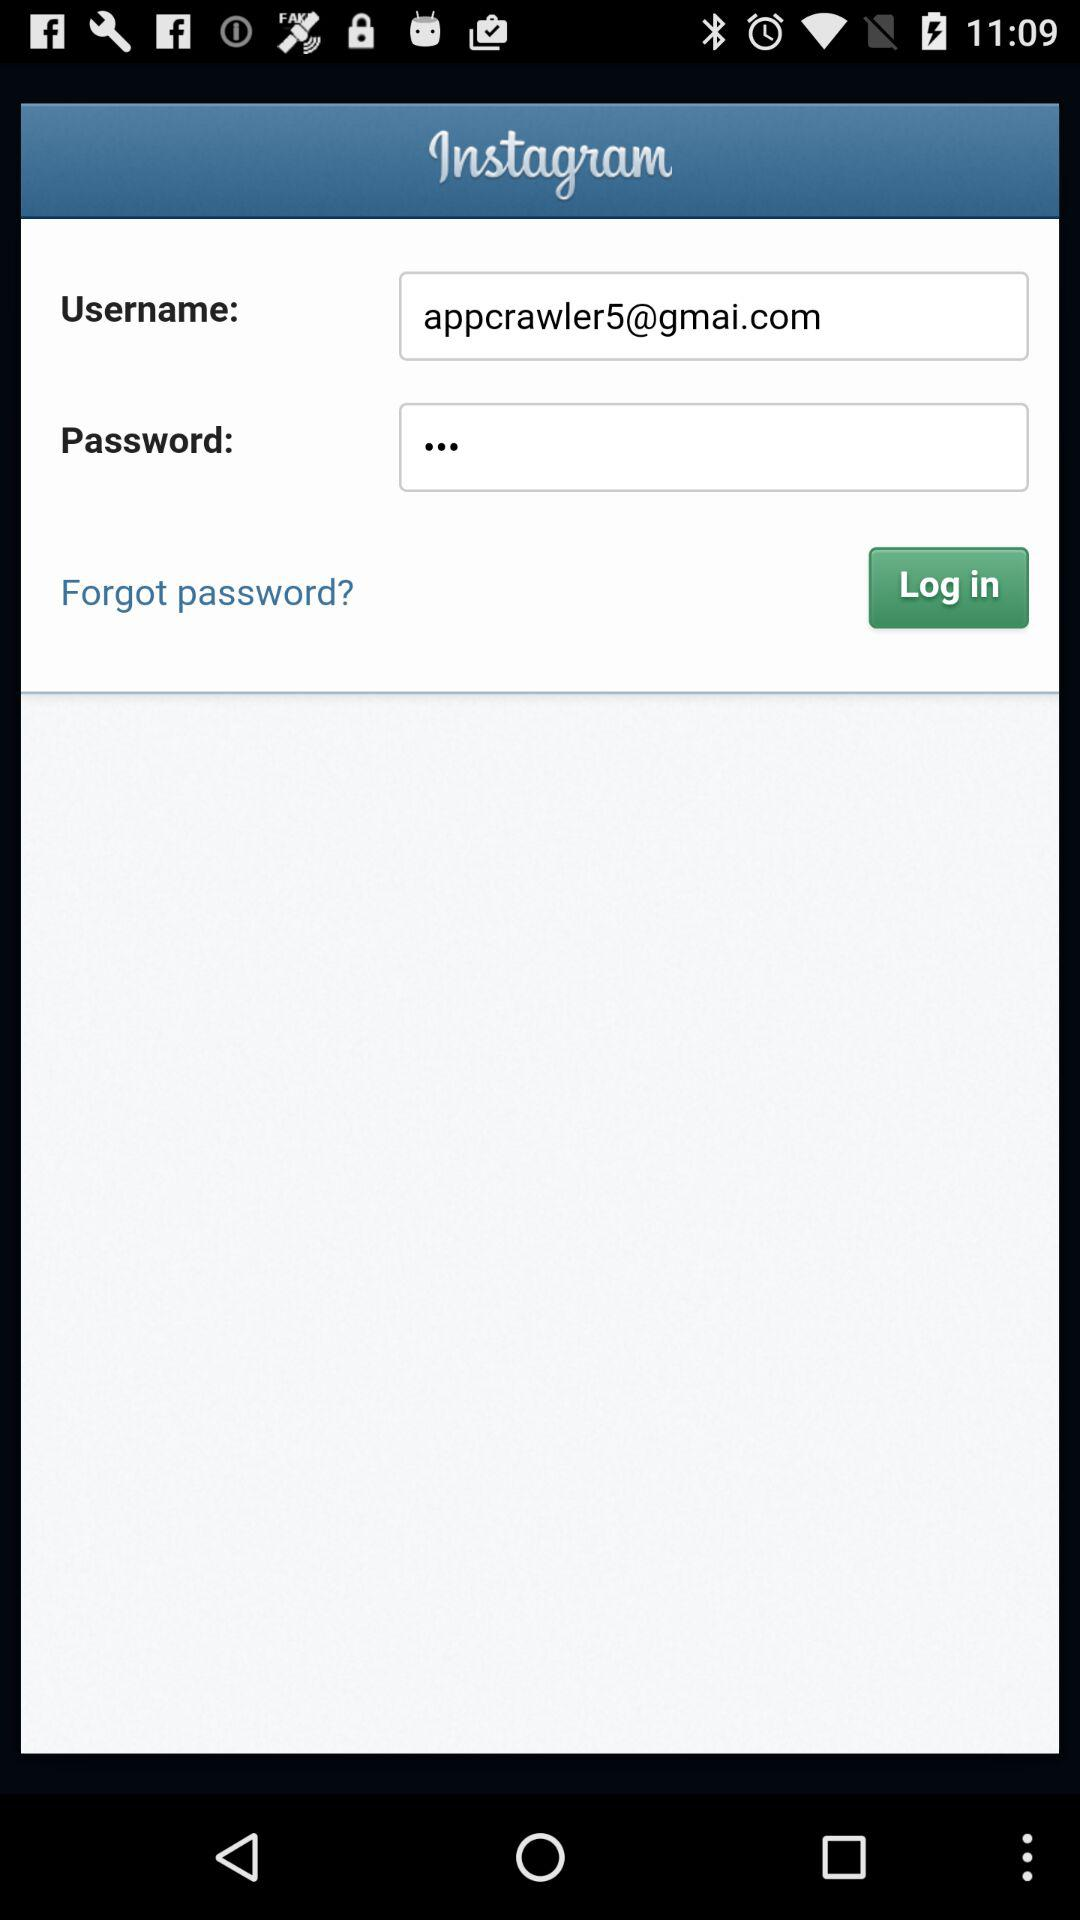How many fields are there in the form?
Answer the question using a single word or phrase. 2 